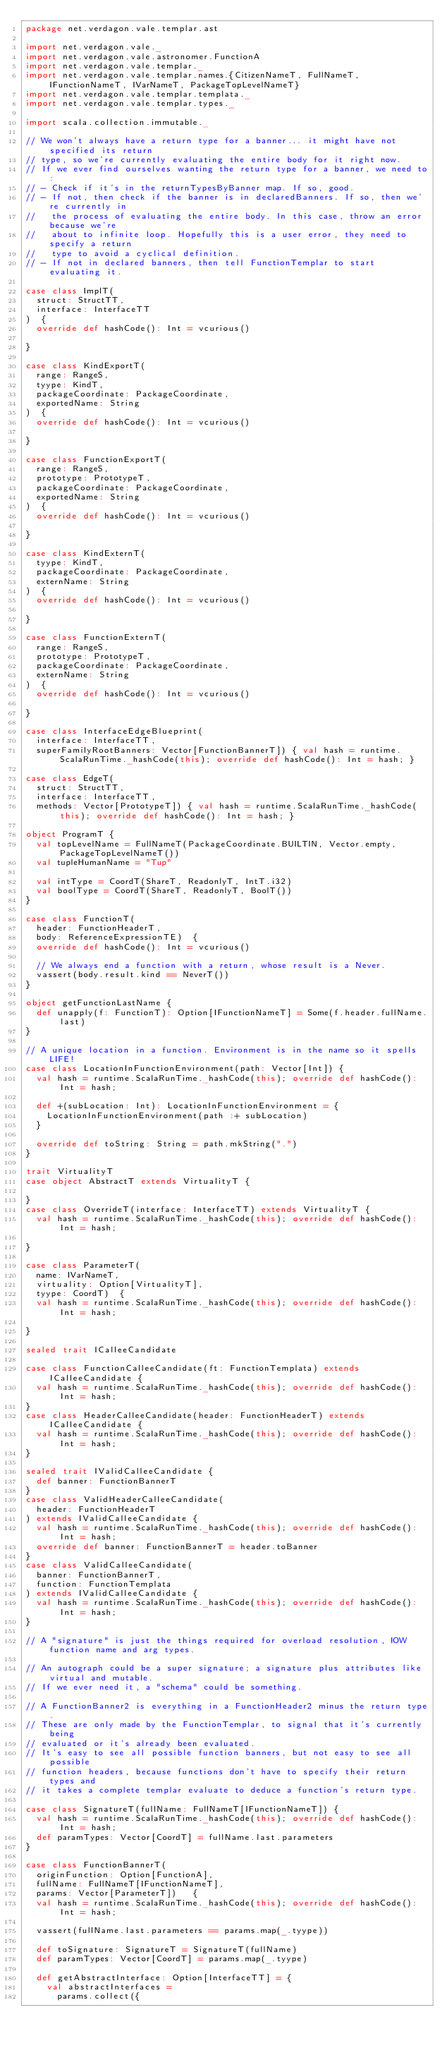Convert code to text. <code><loc_0><loc_0><loc_500><loc_500><_Scala_>package net.verdagon.vale.templar.ast

import net.verdagon.vale._
import net.verdagon.vale.astronomer.FunctionA
import net.verdagon.vale.templar._
import net.verdagon.vale.templar.names.{CitizenNameT, FullNameT, IFunctionNameT, IVarNameT, PackageTopLevelNameT}
import net.verdagon.vale.templar.templata._
import net.verdagon.vale.templar.types._

import scala.collection.immutable._

// We won't always have a return type for a banner... it might have not specified its return
// type, so we're currently evaluating the entire body for it right now.
// If we ever find ourselves wanting the return type for a banner, we need to:
// - Check if it's in the returnTypesByBanner map. If so, good.
// - If not, then check if the banner is in declaredBanners. If so, then we're currently in
//   the process of evaluating the entire body. In this case, throw an error because we're
//   about to infinite loop. Hopefully this is a user error, they need to specify a return
//   type to avoid a cyclical definition.
// - If not in declared banners, then tell FunctionTemplar to start evaluating it.

case class ImplT(
  struct: StructTT,
  interface: InterfaceTT
)  {
  override def hashCode(): Int = vcurious()

}

case class KindExportT(
  range: RangeS,
  tyype: KindT,
  packageCoordinate: PackageCoordinate,
  exportedName: String
)  {
  override def hashCode(): Int = vcurious()

}

case class FunctionExportT(
  range: RangeS,
  prototype: PrototypeT,
  packageCoordinate: PackageCoordinate,
  exportedName: String
)  {
  override def hashCode(): Int = vcurious()

}

case class KindExternT(
  tyype: KindT,
  packageCoordinate: PackageCoordinate,
  externName: String
)  {
  override def hashCode(): Int = vcurious()

}

case class FunctionExternT(
  range: RangeS,
  prototype: PrototypeT,
  packageCoordinate: PackageCoordinate,
  externName: String
)  {
  override def hashCode(): Int = vcurious()

}

case class InterfaceEdgeBlueprint(
  interface: InterfaceTT,
  superFamilyRootBanners: Vector[FunctionBannerT]) { val hash = runtime.ScalaRunTime._hashCode(this); override def hashCode(): Int = hash; }

case class EdgeT(
  struct: StructTT,
  interface: InterfaceTT,
  methods: Vector[PrototypeT]) { val hash = runtime.ScalaRunTime._hashCode(this); override def hashCode(): Int = hash; }

object ProgramT {
  val topLevelName = FullNameT(PackageCoordinate.BUILTIN, Vector.empty, PackageTopLevelNameT())
  val tupleHumanName = "Tup"

  val intType = CoordT(ShareT, ReadonlyT, IntT.i32)
  val boolType = CoordT(ShareT, ReadonlyT, BoolT())
}

case class FunctionT(
  header: FunctionHeaderT,
  body: ReferenceExpressionTE)  {
  override def hashCode(): Int = vcurious()

  // We always end a function with a return, whose result is a Never.
  vassert(body.result.kind == NeverT())
}

object getFunctionLastName {
  def unapply(f: FunctionT): Option[IFunctionNameT] = Some(f.header.fullName.last)
}

// A unique location in a function. Environment is in the name so it spells LIFE!
case class LocationInFunctionEnvironment(path: Vector[Int]) {
  val hash = runtime.ScalaRunTime._hashCode(this); override def hashCode(): Int = hash;

  def +(subLocation: Int): LocationInFunctionEnvironment = {
    LocationInFunctionEnvironment(path :+ subLocation)
  }

  override def toString: String = path.mkString(".")
}

trait VirtualityT
case object AbstractT extends VirtualityT {

}
case class OverrideT(interface: InterfaceTT) extends VirtualityT {
  val hash = runtime.ScalaRunTime._hashCode(this); override def hashCode(): Int = hash;

}

case class ParameterT(
  name: IVarNameT,
  virtuality: Option[VirtualityT],
  tyype: CoordT)  {
  val hash = runtime.ScalaRunTime._hashCode(this); override def hashCode(): Int = hash;

}

sealed trait ICalleeCandidate

case class FunctionCalleeCandidate(ft: FunctionTemplata) extends ICalleeCandidate {
  val hash = runtime.ScalaRunTime._hashCode(this); override def hashCode(): Int = hash;
}
case class HeaderCalleeCandidate(header: FunctionHeaderT) extends ICalleeCandidate {
  val hash = runtime.ScalaRunTime._hashCode(this); override def hashCode(): Int = hash;
}

sealed trait IValidCalleeCandidate {
  def banner: FunctionBannerT
}
case class ValidHeaderCalleeCandidate(
  header: FunctionHeaderT
) extends IValidCalleeCandidate {
  val hash = runtime.ScalaRunTime._hashCode(this); override def hashCode(): Int = hash;
  override def banner: FunctionBannerT = header.toBanner
}
case class ValidCalleeCandidate(
  banner: FunctionBannerT,
  function: FunctionTemplata
) extends IValidCalleeCandidate {
  val hash = runtime.ScalaRunTime._hashCode(this); override def hashCode(): Int = hash;
}

// A "signature" is just the things required for overload resolution, IOW function name and arg types.

// An autograph could be a super signature; a signature plus attributes like virtual and mutable.
// If we ever need it, a "schema" could be something.

// A FunctionBanner2 is everything in a FunctionHeader2 minus the return type.
// These are only made by the FunctionTemplar, to signal that it's currently being
// evaluated or it's already been evaluated.
// It's easy to see all possible function banners, but not easy to see all possible
// function headers, because functions don't have to specify their return types and
// it takes a complete templar evaluate to deduce a function's return type.

case class SignatureT(fullName: FullNameT[IFunctionNameT]) {
  val hash = runtime.ScalaRunTime._hashCode(this); override def hashCode(): Int = hash;
  def paramTypes: Vector[CoordT] = fullName.last.parameters
}

case class FunctionBannerT(
  originFunction: Option[FunctionA],
  fullName: FullNameT[IFunctionNameT],
  params: Vector[ParameterT])   {
  val hash = runtime.ScalaRunTime._hashCode(this); override def hashCode(): Int = hash;

  vassert(fullName.last.parameters == params.map(_.tyype))

  def toSignature: SignatureT = SignatureT(fullName)
  def paramTypes: Vector[CoordT] = params.map(_.tyype)

  def getAbstractInterface: Option[InterfaceTT] = {
    val abstractInterfaces =
      params.collect({</code> 